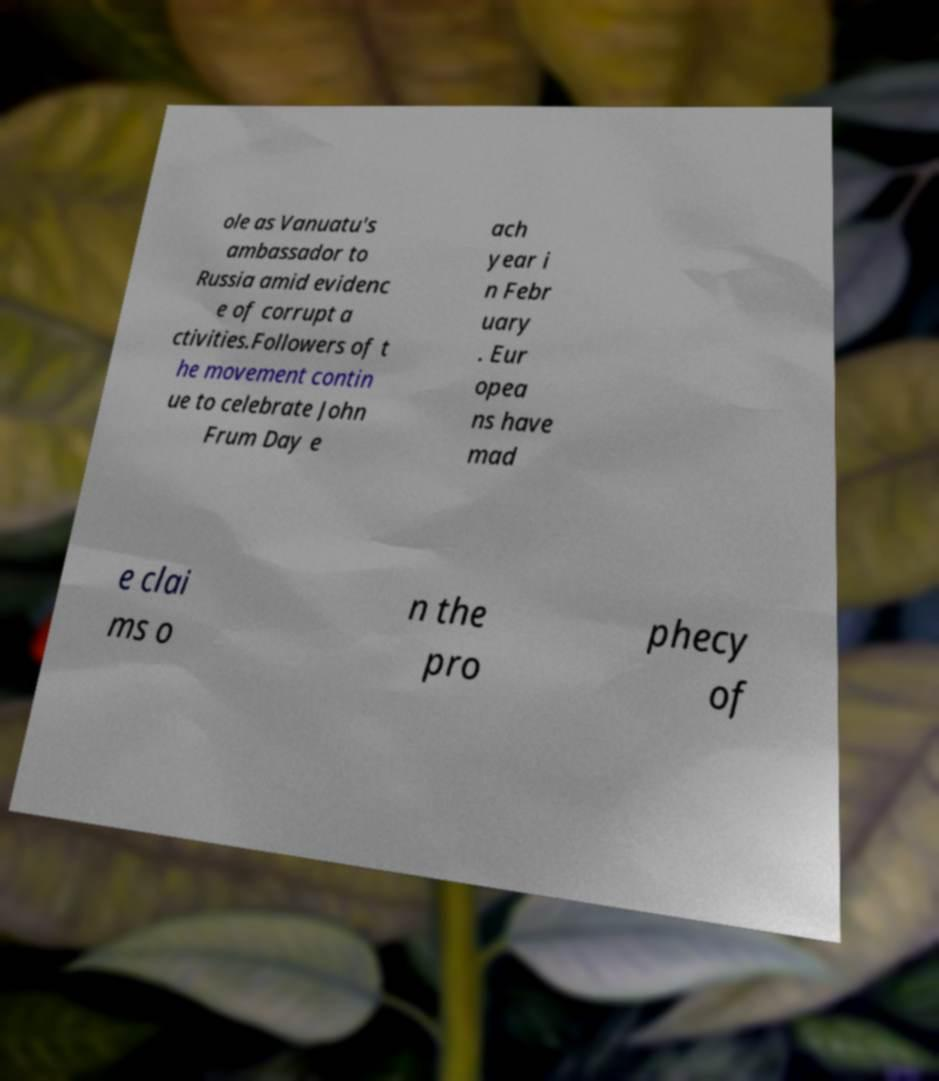Could you assist in decoding the text presented in this image and type it out clearly? ole as Vanuatu's ambassador to Russia amid evidenc e of corrupt a ctivities.Followers of t he movement contin ue to celebrate John Frum Day e ach year i n Febr uary . Eur opea ns have mad e clai ms o n the pro phecy of 